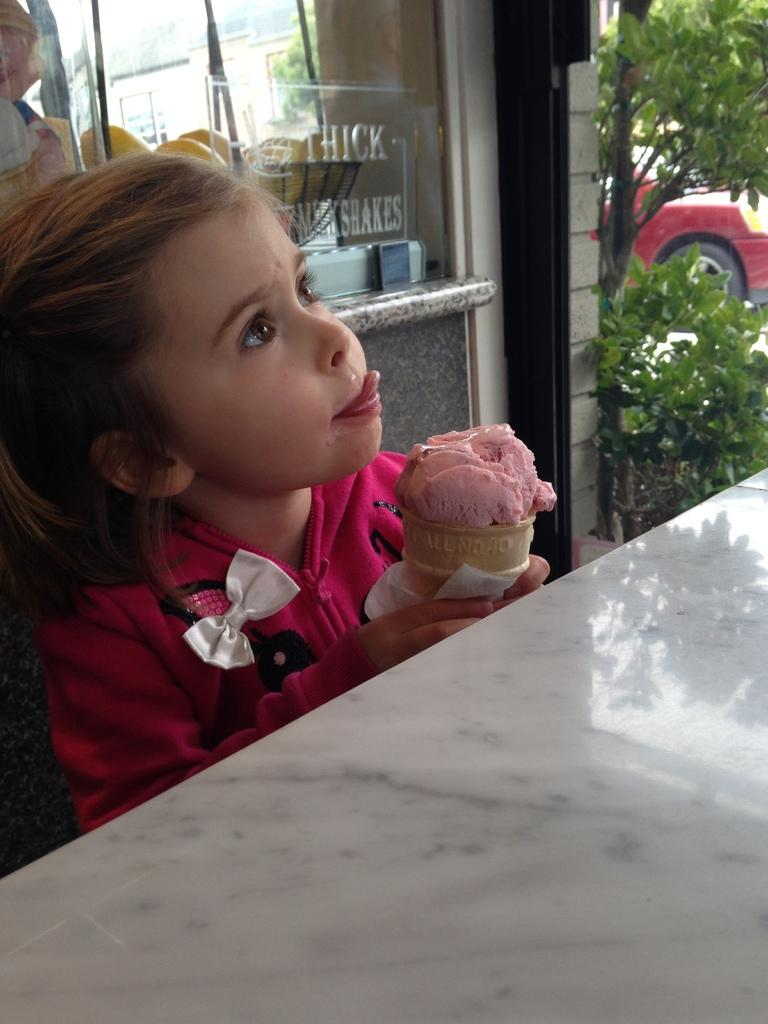What is the main subject of the image? There is a child in the image. What is the child wearing? The child is wearing a dress. What is the child holding in the image? The child is holding an ice-cream. Can you describe the background of the image? There are objects, plants, a vehicle, and a building in the background of the image. What type of yak can be seen in the image? There is no yak present in the image. What is the maid doing in the image? There is no maid present in the image. 